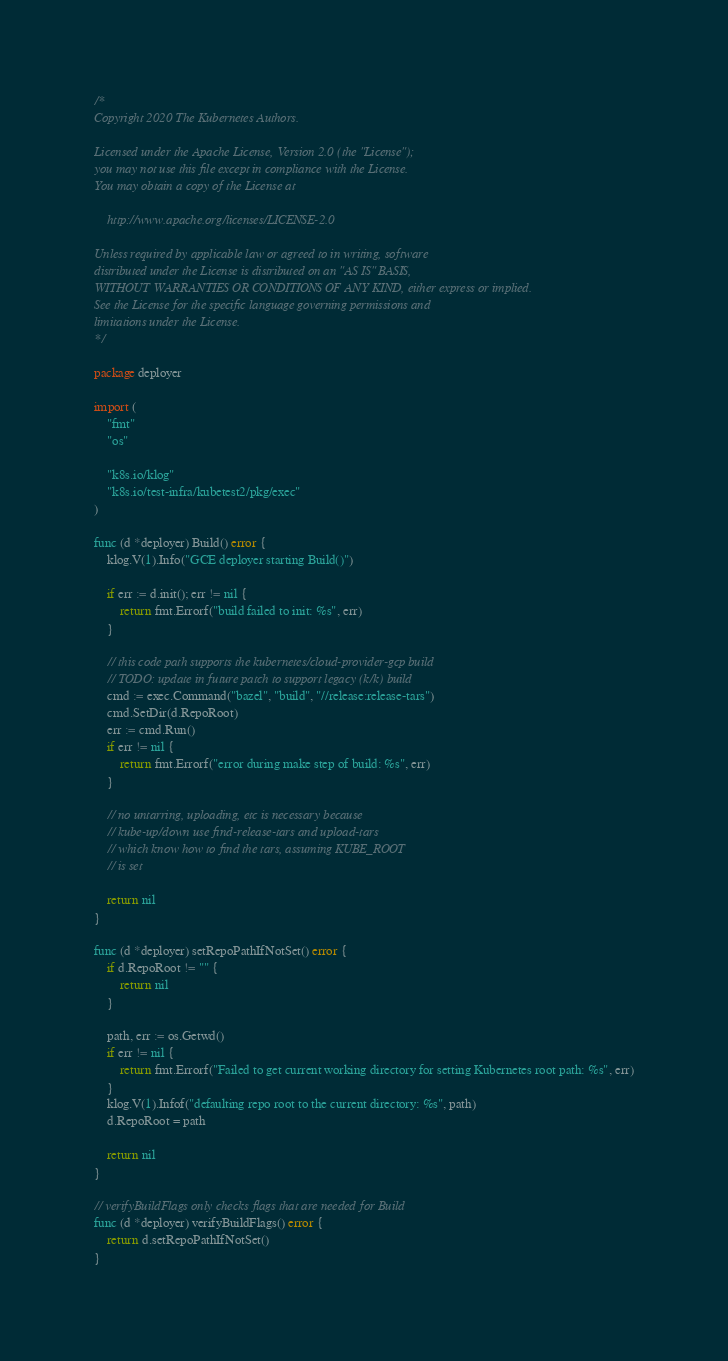<code> <loc_0><loc_0><loc_500><loc_500><_Go_>/*
Copyright 2020 The Kubernetes Authors.

Licensed under the Apache License, Version 2.0 (the "License");
you may not use this file except in compliance with the License.
You may obtain a copy of the License at

    http://www.apache.org/licenses/LICENSE-2.0

Unless required by applicable law or agreed to in writing, software
distributed under the License is distributed on an "AS IS" BASIS,
WITHOUT WARRANTIES OR CONDITIONS OF ANY KIND, either express or implied.
See the License for the specific language governing permissions and
limitations under the License.
*/

package deployer

import (
	"fmt"
	"os"

	"k8s.io/klog"
	"k8s.io/test-infra/kubetest2/pkg/exec"
)

func (d *deployer) Build() error {
	klog.V(1).Info("GCE deployer starting Build()")

	if err := d.init(); err != nil {
		return fmt.Errorf("build failed to init: %s", err)
	}

	// this code path supports the kubernetes/cloud-provider-gcp build
	// TODO: update in future patch to support legacy (k/k) build
	cmd := exec.Command("bazel", "build", "//release:release-tars")
	cmd.SetDir(d.RepoRoot)
	err := cmd.Run()
	if err != nil {
		return fmt.Errorf("error during make step of build: %s", err)
	}

	// no untarring, uploading, etc is necessary because
	// kube-up/down use find-release-tars and upload-tars
	// which know how to find the tars, assuming KUBE_ROOT
	// is set

	return nil
}

func (d *deployer) setRepoPathIfNotSet() error {
	if d.RepoRoot != "" {
		return nil
	}

	path, err := os.Getwd()
	if err != nil {
		return fmt.Errorf("Failed to get current working directory for setting Kubernetes root path: %s", err)
	}
	klog.V(1).Infof("defaulting repo root to the current directory: %s", path)
	d.RepoRoot = path

	return nil
}

// verifyBuildFlags only checks flags that are needed for Build
func (d *deployer) verifyBuildFlags() error {
	return d.setRepoPathIfNotSet()
}
</code> 